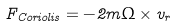Convert formula to latex. <formula><loc_0><loc_0><loc_500><loc_500>F _ { C o r i o l i s } = - 2 m { \Omega } \times v _ { r }</formula> 